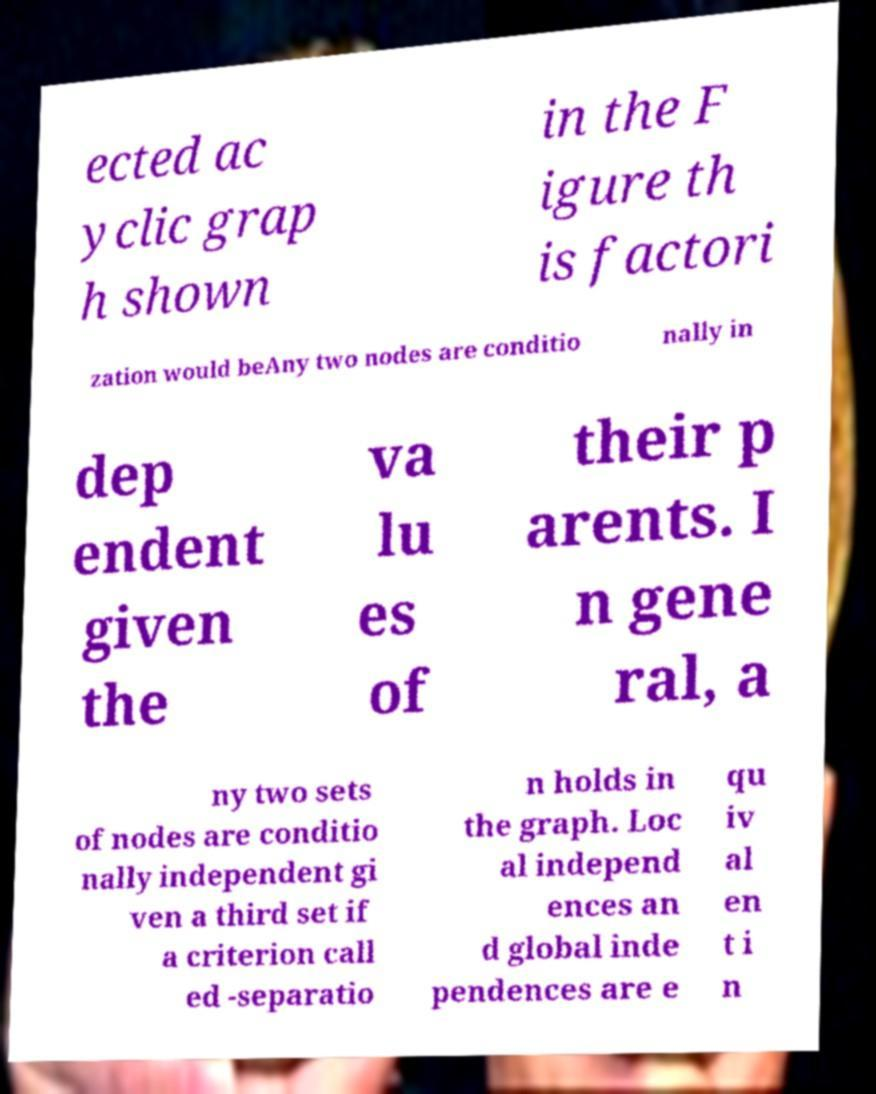For documentation purposes, I need the text within this image transcribed. Could you provide that? ected ac yclic grap h shown in the F igure th is factori zation would beAny two nodes are conditio nally in dep endent given the va lu es of their p arents. I n gene ral, a ny two sets of nodes are conditio nally independent gi ven a third set if a criterion call ed -separatio n holds in the graph. Loc al independ ences an d global inde pendences are e qu iv al en t i n 